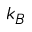Convert formula to latex. <formula><loc_0><loc_0><loc_500><loc_500>k _ { B }</formula> 